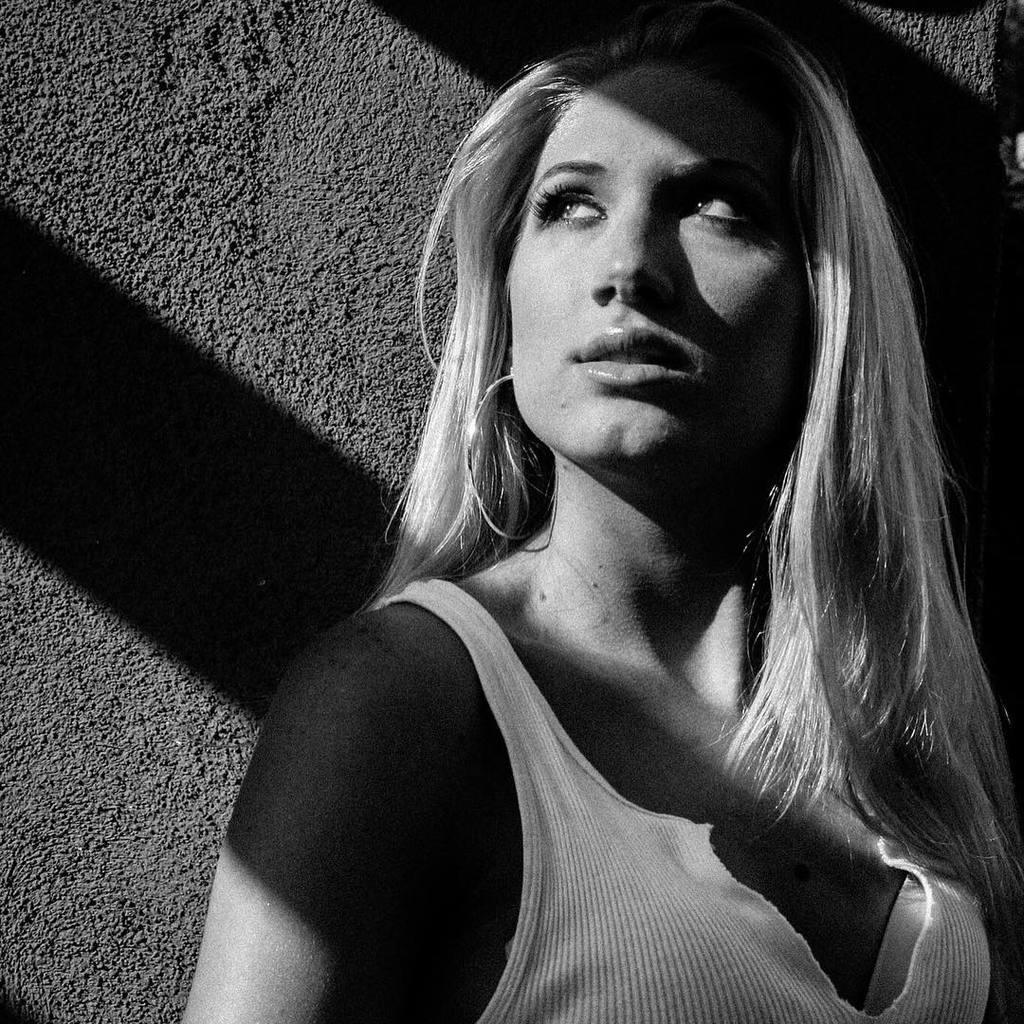Who is present in the image? There is a woman in the image. What is the woman wearing? The woman is wearing a white dress. What can be seen in the background of the image? There is a wall in the background of the image. What is visible on the wall? There is a shadow on the wall. What type of card is the woman holding in the image? There is no card present in the image. What activity is the woman participating in while getting a haircut? There is no haircut or activity visible in the image; it only shows a woman wearing a white dress with a shadow on the wall. 